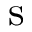<formula> <loc_0><loc_0><loc_500><loc_500>s</formula> 